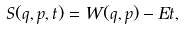<formula> <loc_0><loc_0><loc_500><loc_500>S ( q , p , t ) = W ( q , p ) - E t ,</formula> 